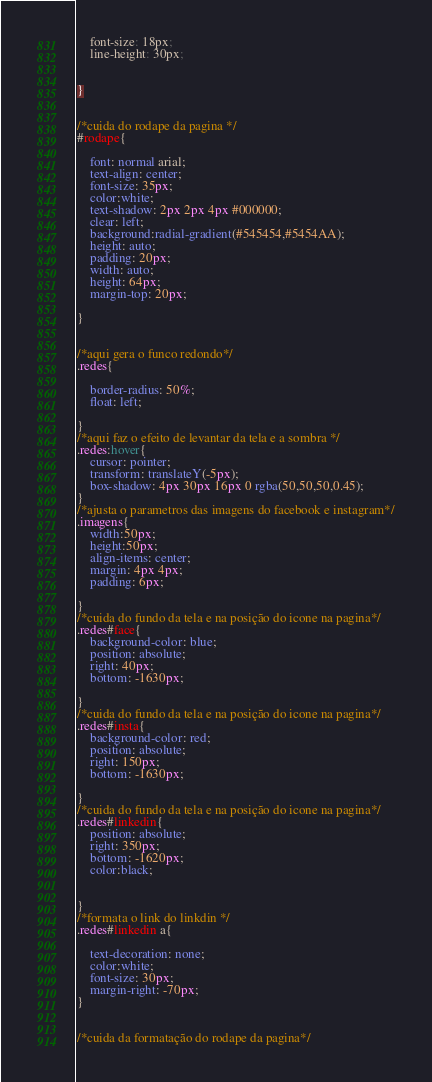<code> <loc_0><loc_0><loc_500><loc_500><_CSS_>	font-size: 18px;
	line-height: 30px;


}


/*cuida do rodape da pagina */
#rodape{
	
	font: normal arial;
	text-align: center;
	font-size: 35px;
	color:white;
	text-shadow: 2px 2px 4px #000000;
	clear: left;
	background:radial-gradient(#545454,#5454AA);
	height: auto;
	padding: 20px;
	width: auto;
	height: 64px;
	margin-top: 20px;

}


/*aqui gera o funco redondo*/
.redes{
	
	border-radius: 50%;
	float: left;

}
/*aqui faz o efeito de levantar da tela e a sombra */
.redes:hover{
	cursor: pointer;
	transform: translateY(-5px);
	box-shadow: 4px 30px 16px 0 rgba(50,50,50,0.45);
}
/*ajusta o parametros das imagens do facebook e instagram*/
.imagens{
	width:50px; 
	height:50px;
	align-items: center;
	margin: 4px 4px;
	padding: 6px;
	
}
/*cuida do fundo da tela e na posição do icone na pagina*/
.redes#face{
	background-color: blue;
	position: absolute;
	right: 40px;
	bottom: -1630px;
	
}
/*cuida do fundo da tela e na posição do icone na pagina*/
.redes#insta{
	background-color: red;
	position: absolute;
	right: 150px;
	bottom: -1630px;

}
/*cuida do fundo da tela e na posição do icone na pagina*/
.redes#linkedin{
	position: absolute;
	right: 350px;
	bottom: -1620px;
	color:black;


}
/*formata o link do linkdin */
.redes#linkedin a{

	text-decoration: none;
	color:white;
	font-size: 30px;
	margin-right: -70px;
}	


/*cuida da formatação do rodape da pagina*/





</code> 